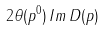<formula> <loc_0><loc_0><loc_500><loc_500>2 \theta ( p ^ { 0 } ) \, I m \, D ( p )</formula> 